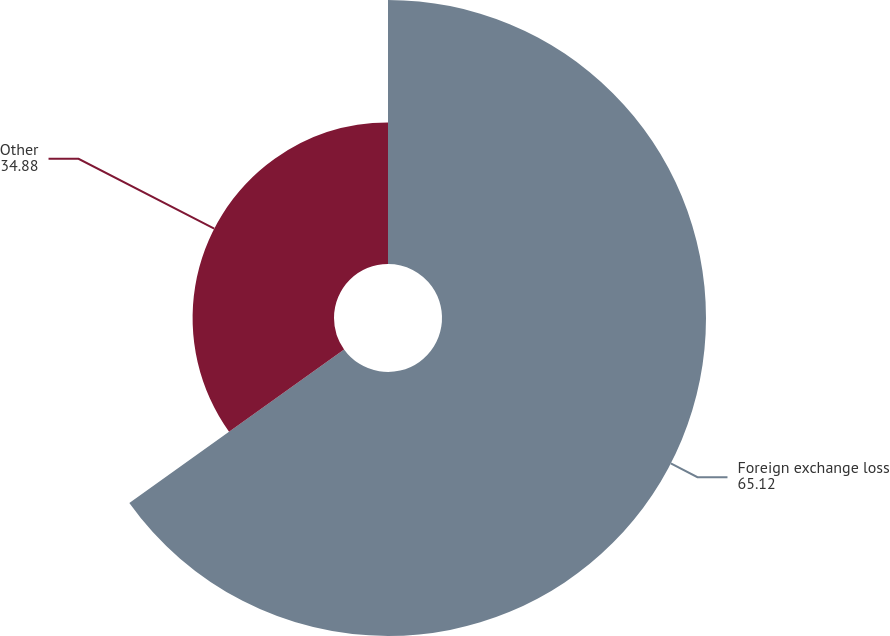Convert chart to OTSL. <chart><loc_0><loc_0><loc_500><loc_500><pie_chart><fcel>Foreign exchange loss<fcel>Other<nl><fcel>65.12%<fcel>34.88%<nl></chart> 